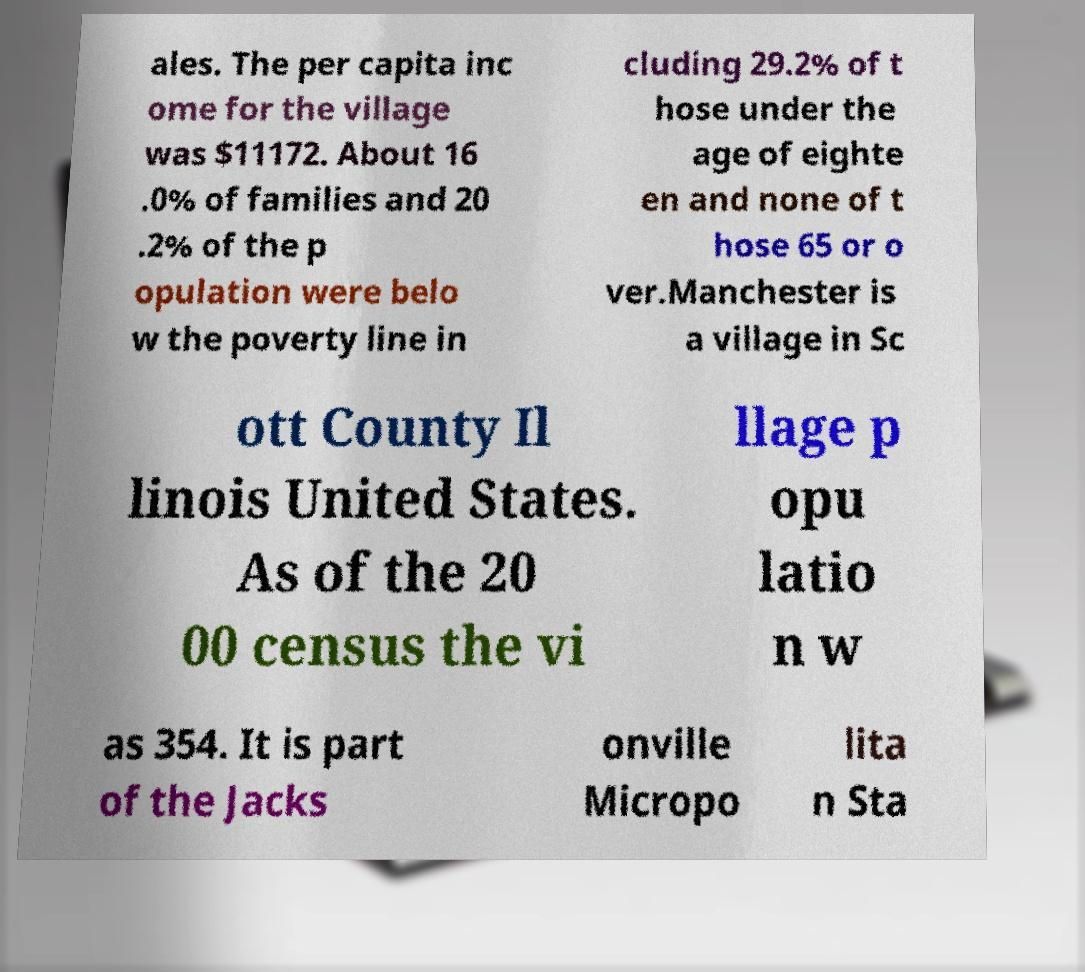Can you accurately transcribe the text from the provided image for me? ales. The per capita inc ome for the village was $11172. About 16 .0% of families and 20 .2% of the p opulation were belo w the poverty line in cluding 29.2% of t hose under the age of eighte en and none of t hose 65 or o ver.Manchester is a village in Sc ott County Il linois United States. As of the 20 00 census the vi llage p opu latio n w as 354. It is part of the Jacks onville Micropo lita n Sta 